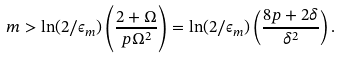<formula> <loc_0><loc_0><loc_500><loc_500>m > \ln ( 2 / \epsilon _ { m } ) \left ( \frac { 2 + \Omega } { p \Omega ^ { 2 } } \right ) = \ln ( 2 / \epsilon _ { m } ) \left ( \frac { 8 p + 2 \delta } { \delta ^ { 2 } } \right ) .</formula> 